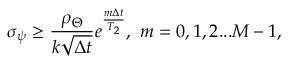Convert formula to latex. <formula><loc_0><loc_0><loc_500><loc_500>\sigma _ { \psi } \geq \frac { \rho _ { \Theta } } { k \sqrt { \Delta t } } e ^ { \frac { m \Delta t } { T _ { 2 } } } , m = 0 , 1 , 2 \dots M - 1 ,</formula> 